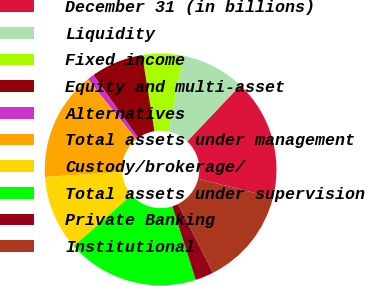<chart> <loc_0><loc_0><loc_500><loc_500><pie_chart><fcel>December 31 (in billions)<fcel>Liquidity<fcel>Fixed income<fcel>Equity and multi-asset<fcel>Alternatives<fcel>Total assets under management<fcel>Custody/brokerage/<fcel>Total assets under supervision<fcel>Private Banking<fcel>Institutional<nl><fcel>16.82%<fcel>8.89%<fcel>5.72%<fcel>7.31%<fcel>0.95%<fcel>15.23%<fcel>10.48%<fcel>18.4%<fcel>2.55%<fcel>13.65%<nl></chart> 